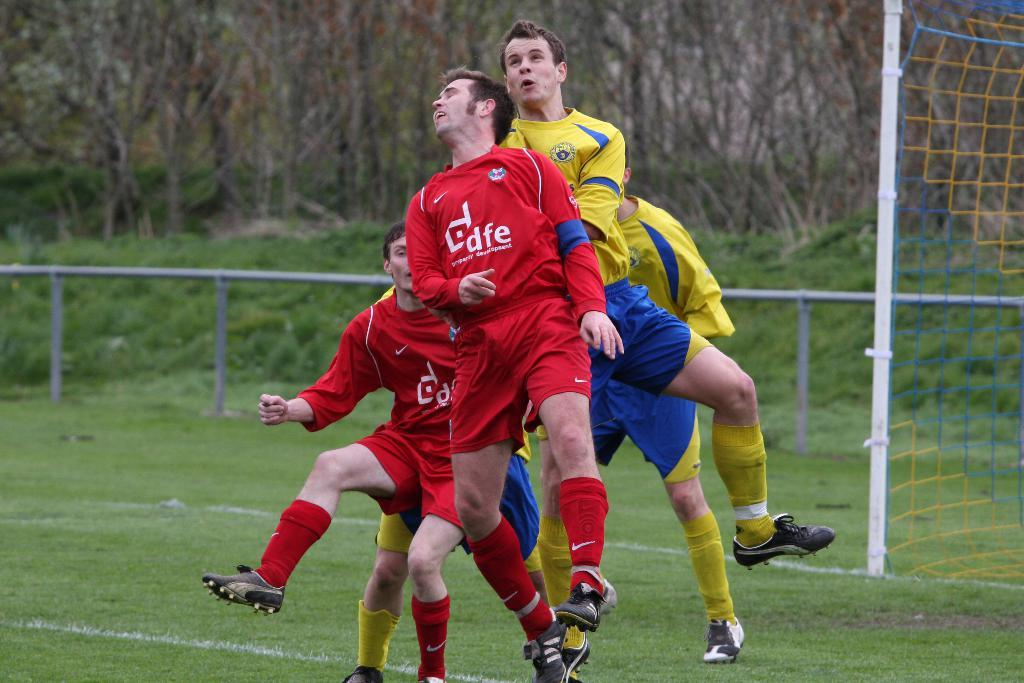Provide a one-sentence caption for the provided image. DFE soccer players blocking a goal at the end field. 